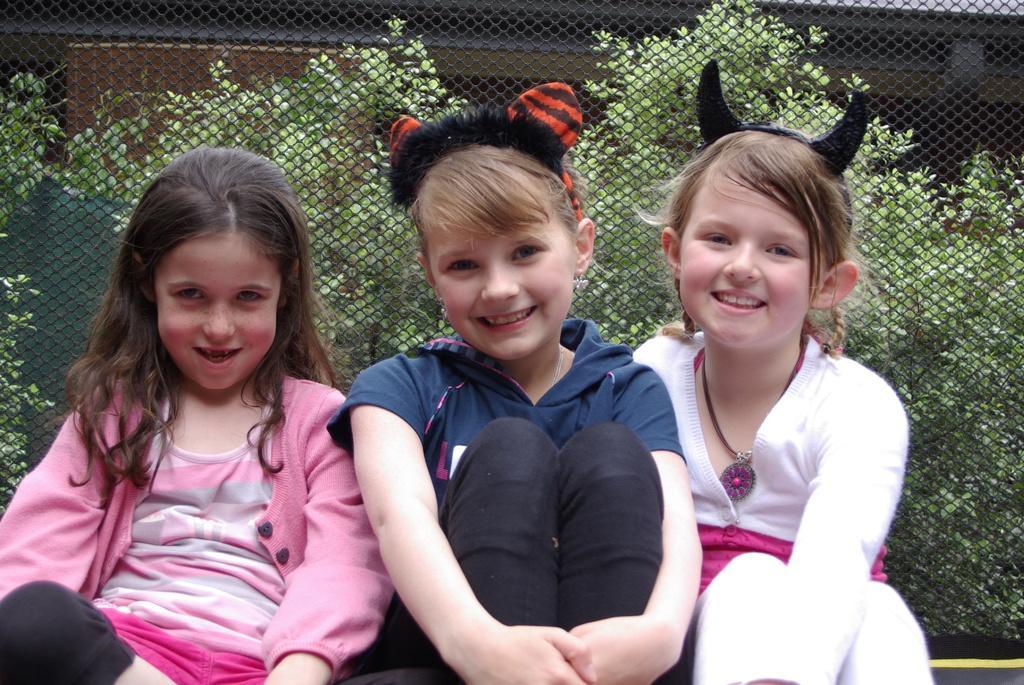Can you describe this image briefly? There are three girls in different color dresses, smiling and sitting. Beside them, there is a fence. In the background, there are plants. And the background is dark in color. 